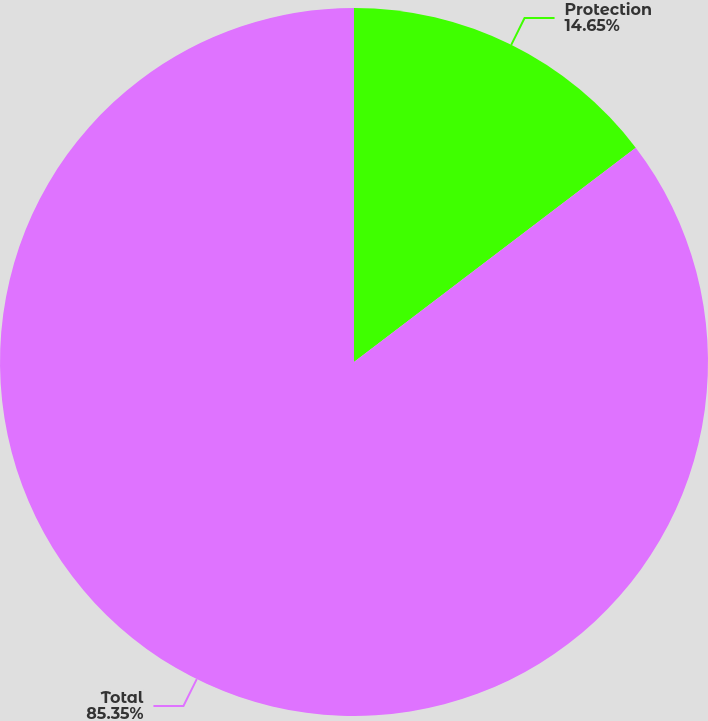<chart> <loc_0><loc_0><loc_500><loc_500><pie_chart><fcel>Protection<fcel>Total<nl><fcel>14.65%<fcel>85.35%<nl></chart> 